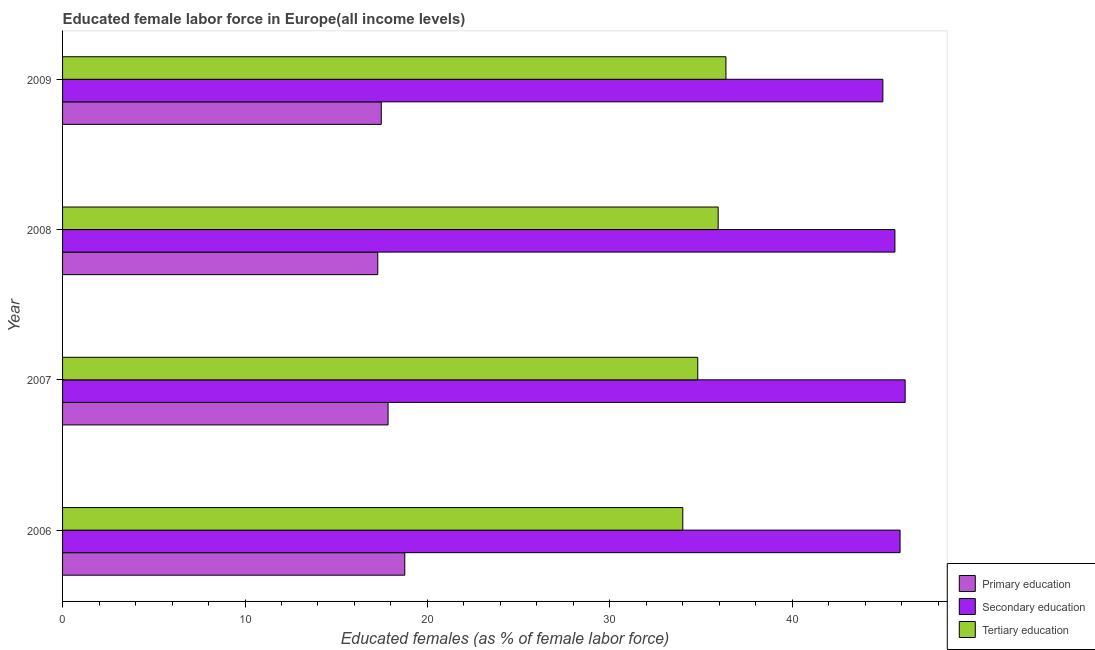How many different coloured bars are there?
Offer a very short reply. 3. How many groups of bars are there?
Your answer should be compact. 4. Are the number of bars per tick equal to the number of legend labels?
Offer a terse response. Yes. Are the number of bars on each tick of the Y-axis equal?
Make the answer very short. Yes. How many bars are there on the 3rd tick from the top?
Keep it short and to the point. 3. How many bars are there on the 3rd tick from the bottom?
Your answer should be compact. 3. What is the percentage of female labor force who received tertiary education in 2007?
Keep it short and to the point. 34.82. Across all years, what is the maximum percentage of female labor force who received primary education?
Provide a succinct answer. 18.76. Across all years, what is the minimum percentage of female labor force who received tertiary education?
Offer a very short reply. 34. In which year was the percentage of female labor force who received primary education minimum?
Your answer should be compact. 2008. What is the total percentage of female labor force who received tertiary education in the graph?
Ensure brevity in your answer.  141.11. What is the difference between the percentage of female labor force who received tertiary education in 2008 and that in 2009?
Make the answer very short. -0.42. What is the difference between the percentage of female labor force who received tertiary education in 2007 and the percentage of female labor force who received primary education in 2009?
Your answer should be compact. 17.35. What is the average percentage of female labor force who received tertiary education per year?
Your answer should be compact. 35.28. In the year 2007, what is the difference between the percentage of female labor force who received primary education and percentage of female labor force who received secondary education?
Ensure brevity in your answer.  -28.34. In how many years, is the percentage of female labor force who received tertiary education greater than 30 %?
Keep it short and to the point. 4. What is the ratio of the percentage of female labor force who received primary education in 2008 to that in 2009?
Make the answer very short. 0.99. What is the difference between the highest and the second highest percentage of female labor force who received primary education?
Offer a very short reply. 0.92. What is the difference between the highest and the lowest percentage of female labor force who received tertiary education?
Your answer should be compact. 2.36. Is the sum of the percentage of female labor force who received primary education in 2006 and 2008 greater than the maximum percentage of female labor force who received secondary education across all years?
Offer a very short reply. No. What does the 2nd bar from the top in 2008 represents?
Make the answer very short. Secondary education. What does the 3rd bar from the bottom in 2008 represents?
Ensure brevity in your answer.  Tertiary education. How many bars are there?
Offer a very short reply. 12. Are all the bars in the graph horizontal?
Ensure brevity in your answer.  Yes. How many years are there in the graph?
Provide a short and direct response. 4. What is the difference between two consecutive major ticks on the X-axis?
Your response must be concise. 10. Does the graph contain grids?
Provide a short and direct response. No. How many legend labels are there?
Ensure brevity in your answer.  3. What is the title of the graph?
Keep it short and to the point. Educated female labor force in Europe(all income levels). What is the label or title of the X-axis?
Keep it short and to the point. Educated females (as % of female labor force). What is the Educated females (as % of female labor force) of Primary education in 2006?
Provide a short and direct response. 18.76. What is the Educated females (as % of female labor force) of Secondary education in 2006?
Give a very brief answer. 45.91. What is the Educated females (as % of female labor force) in Tertiary education in 2006?
Give a very brief answer. 34. What is the Educated females (as % of female labor force) of Primary education in 2007?
Give a very brief answer. 17.84. What is the Educated females (as % of female labor force) of Secondary education in 2007?
Keep it short and to the point. 46.18. What is the Educated females (as % of female labor force) of Tertiary education in 2007?
Provide a short and direct response. 34.82. What is the Educated females (as % of female labor force) of Primary education in 2008?
Offer a very short reply. 17.28. What is the Educated females (as % of female labor force) in Secondary education in 2008?
Offer a terse response. 45.62. What is the Educated females (as % of female labor force) in Tertiary education in 2008?
Offer a very short reply. 35.94. What is the Educated females (as % of female labor force) in Primary education in 2009?
Your response must be concise. 17.47. What is the Educated females (as % of female labor force) in Secondary education in 2009?
Offer a very short reply. 44.96. What is the Educated females (as % of female labor force) in Tertiary education in 2009?
Provide a succinct answer. 36.36. Across all years, what is the maximum Educated females (as % of female labor force) in Primary education?
Offer a very short reply. 18.76. Across all years, what is the maximum Educated females (as % of female labor force) of Secondary education?
Ensure brevity in your answer.  46.18. Across all years, what is the maximum Educated females (as % of female labor force) in Tertiary education?
Provide a short and direct response. 36.36. Across all years, what is the minimum Educated females (as % of female labor force) of Primary education?
Your answer should be compact. 17.28. Across all years, what is the minimum Educated females (as % of female labor force) in Secondary education?
Keep it short and to the point. 44.96. Across all years, what is the minimum Educated females (as % of female labor force) in Tertiary education?
Offer a very short reply. 34. What is the total Educated females (as % of female labor force) in Primary education in the graph?
Offer a terse response. 71.35. What is the total Educated females (as % of female labor force) of Secondary education in the graph?
Your answer should be very brief. 182.68. What is the total Educated females (as % of female labor force) of Tertiary education in the graph?
Your response must be concise. 141.11. What is the difference between the Educated females (as % of female labor force) of Primary education in 2006 and that in 2007?
Give a very brief answer. 0.92. What is the difference between the Educated females (as % of female labor force) in Secondary education in 2006 and that in 2007?
Give a very brief answer. -0.28. What is the difference between the Educated females (as % of female labor force) of Tertiary education in 2006 and that in 2007?
Offer a terse response. -0.82. What is the difference between the Educated females (as % of female labor force) in Primary education in 2006 and that in 2008?
Make the answer very short. 1.48. What is the difference between the Educated females (as % of female labor force) of Secondary education in 2006 and that in 2008?
Offer a terse response. 0.28. What is the difference between the Educated females (as % of female labor force) of Tertiary education in 2006 and that in 2008?
Give a very brief answer. -1.94. What is the difference between the Educated females (as % of female labor force) of Primary education in 2006 and that in 2009?
Your answer should be compact. 1.29. What is the difference between the Educated females (as % of female labor force) in Secondary education in 2006 and that in 2009?
Your response must be concise. 0.94. What is the difference between the Educated females (as % of female labor force) of Tertiary education in 2006 and that in 2009?
Offer a terse response. -2.36. What is the difference between the Educated females (as % of female labor force) of Primary education in 2007 and that in 2008?
Provide a short and direct response. 0.56. What is the difference between the Educated females (as % of female labor force) of Secondary education in 2007 and that in 2008?
Give a very brief answer. 0.56. What is the difference between the Educated females (as % of female labor force) in Tertiary education in 2007 and that in 2008?
Offer a very short reply. -1.12. What is the difference between the Educated females (as % of female labor force) of Primary education in 2007 and that in 2009?
Give a very brief answer. 0.37. What is the difference between the Educated females (as % of female labor force) in Secondary education in 2007 and that in 2009?
Ensure brevity in your answer.  1.22. What is the difference between the Educated females (as % of female labor force) in Tertiary education in 2007 and that in 2009?
Your response must be concise. -1.54. What is the difference between the Educated females (as % of female labor force) in Primary education in 2008 and that in 2009?
Keep it short and to the point. -0.19. What is the difference between the Educated females (as % of female labor force) of Secondary education in 2008 and that in 2009?
Give a very brief answer. 0.66. What is the difference between the Educated females (as % of female labor force) of Tertiary education in 2008 and that in 2009?
Make the answer very short. -0.43. What is the difference between the Educated females (as % of female labor force) of Primary education in 2006 and the Educated females (as % of female labor force) of Secondary education in 2007?
Ensure brevity in your answer.  -27.43. What is the difference between the Educated females (as % of female labor force) in Primary education in 2006 and the Educated females (as % of female labor force) in Tertiary education in 2007?
Provide a succinct answer. -16.06. What is the difference between the Educated females (as % of female labor force) of Secondary education in 2006 and the Educated females (as % of female labor force) of Tertiary education in 2007?
Keep it short and to the point. 11.09. What is the difference between the Educated females (as % of female labor force) in Primary education in 2006 and the Educated females (as % of female labor force) in Secondary education in 2008?
Provide a succinct answer. -26.87. What is the difference between the Educated females (as % of female labor force) in Primary education in 2006 and the Educated females (as % of female labor force) in Tertiary education in 2008?
Provide a succinct answer. -17.18. What is the difference between the Educated females (as % of female labor force) of Secondary education in 2006 and the Educated females (as % of female labor force) of Tertiary education in 2008?
Offer a terse response. 9.97. What is the difference between the Educated females (as % of female labor force) of Primary education in 2006 and the Educated females (as % of female labor force) of Secondary education in 2009?
Provide a short and direct response. -26.21. What is the difference between the Educated females (as % of female labor force) in Primary education in 2006 and the Educated females (as % of female labor force) in Tertiary education in 2009?
Your response must be concise. -17.6. What is the difference between the Educated females (as % of female labor force) of Secondary education in 2006 and the Educated females (as % of female labor force) of Tertiary education in 2009?
Provide a succinct answer. 9.54. What is the difference between the Educated females (as % of female labor force) in Primary education in 2007 and the Educated females (as % of female labor force) in Secondary education in 2008?
Make the answer very short. -27.78. What is the difference between the Educated females (as % of female labor force) of Primary education in 2007 and the Educated females (as % of female labor force) of Tertiary education in 2008?
Make the answer very short. -18.09. What is the difference between the Educated females (as % of female labor force) of Secondary education in 2007 and the Educated females (as % of female labor force) of Tertiary education in 2008?
Offer a very short reply. 10.25. What is the difference between the Educated females (as % of female labor force) in Primary education in 2007 and the Educated females (as % of female labor force) in Secondary education in 2009?
Your answer should be very brief. -27.12. What is the difference between the Educated females (as % of female labor force) in Primary education in 2007 and the Educated females (as % of female labor force) in Tertiary education in 2009?
Make the answer very short. -18.52. What is the difference between the Educated females (as % of female labor force) of Secondary education in 2007 and the Educated females (as % of female labor force) of Tertiary education in 2009?
Ensure brevity in your answer.  9.82. What is the difference between the Educated females (as % of female labor force) in Primary education in 2008 and the Educated females (as % of female labor force) in Secondary education in 2009?
Offer a very short reply. -27.68. What is the difference between the Educated females (as % of female labor force) in Primary education in 2008 and the Educated females (as % of female labor force) in Tertiary education in 2009?
Offer a terse response. -19.08. What is the difference between the Educated females (as % of female labor force) of Secondary education in 2008 and the Educated females (as % of female labor force) of Tertiary education in 2009?
Give a very brief answer. 9.26. What is the average Educated females (as % of female labor force) in Primary education per year?
Your answer should be compact. 17.84. What is the average Educated females (as % of female labor force) in Secondary education per year?
Offer a terse response. 45.67. What is the average Educated females (as % of female labor force) of Tertiary education per year?
Your answer should be compact. 35.28. In the year 2006, what is the difference between the Educated females (as % of female labor force) in Primary education and Educated females (as % of female labor force) in Secondary education?
Ensure brevity in your answer.  -27.15. In the year 2006, what is the difference between the Educated females (as % of female labor force) in Primary education and Educated females (as % of female labor force) in Tertiary education?
Keep it short and to the point. -15.24. In the year 2006, what is the difference between the Educated females (as % of female labor force) in Secondary education and Educated females (as % of female labor force) in Tertiary education?
Make the answer very short. 11.91. In the year 2007, what is the difference between the Educated females (as % of female labor force) in Primary education and Educated females (as % of female labor force) in Secondary education?
Give a very brief answer. -28.34. In the year 2007, what is the difference between the Educated females (as % of female labor force) in Primary education and Educated females (as % of female labor force) in Tertiary education?
Offer a very short reply. -16.97. In the year 2007, what is the difference between the Educated females (as % of female labor force) in Secondary education and Educated females (as % of female labor force) in Tertiary education?
Provide a short and direct response. 11.37. In the year 2008, what is the difference between the Educated females (as % of female labor force) of Primary education and Educated females (as % of female labor force) of Secondary education?
Provide a short and direct response. -28.35. In the year 2008, what is the difference between the Educated females (as % of female labor force) of Primary education and Educated females (as % of female labor force) of Tertiary education?
Your response must be concise. -18.66. In the year 2008, what is the difference between the Educated females (as % of female labor force) in Secondary education and Educated females (as % of female labor force) in Tertiary education?
Your response must be concise. 9.69. In the year 2009, what is the difference between the Educated females (as % of female labor force) of Primary education and Educated females (as % of female labor force) of Secondary education?
Your answer should be very brief. -27.49. In the year 2009, what is the difference between the Educated females (as % of female labor force) of Primary education and Educated females (as % of female labor force) of Tertiary education?
Make the answer very short. -18.89. In the year 2009, what is the difference between the Educated females (as % of female labor force) in Secondary education and Educated females (as % of female labor force) in Tertiary education?
Ensure brevity in your answer.  8.6. What is the ratio of the Educated females (as % of female labor force) of Primary education in 2006 to that in 2007?
Make the answer very short. 1.05. What is the ratio of the Educated females (as % of female labor force) in Tertiary education in 2006 to that in 2007?
Provide a succinct answer. 0.98. What is the ratio of the Educated females (as % of female labor force) of Primary education in 2006 to that in 2008?
Your answer should be compact. 1.09. What is the ratio of the Educated females (as % of female labor force) in Tertiary education in 2006 to that in 2008?
Your answer should be very brief. 0.95. What is the ratio of the Educated females (as % of female labor force) in Primary education in 2006 to that in 2009?
Offer a terse response. 1.07. What is the ratio of the Educated females (as % of female labor force) in Secondary education in 2006 to that in 2009?
Your response must be concise. 1.02. What is the ratio of the Educated females (as % of female labor force) of Tertiary education in 2006 to that in 2009?
Keep it short and to the point. 0.94. What is the ratio of the Educated females (as % of female labor force) in Primary education in 2007 to that in 2008?
Your answer should be very brief. 1.03. What is the ratio of the Educated females (as % of female labor force) of Secondary education in 2007 to that in 2008?
Make the answer very short. 1.01. What is the ratio of the Educated females (as % of female labor force) of Tertiary education in 2007 to that in 2008?
Make the answer very short. 0.97. What is the ratio of the Educated females (as % of female labor force) in Primary education in 2007 to that in 2009?
Provide a short and direct response. 1.02. What is the ratio of the Educated females (as % of female labor force) in Secondary education in 2007 to that in 2009?
Provide a short and direct response. 1.03. What is the ratio of the Educated females (as % of female labor force) in Tertiary education in 2007 to that in 2009?
Provide a succinct answer. 0.96. What is the ratio of the Educated females (as % of female labor force) of Primary education in 2008 to that in 2009?
Make the answer very short. 0.99. What is the ratio of the Educated females (as % of female labor force) of Secondary education in 2008 to that in 2009?
Make the answer very short. 1.01. What is the ratio of the Educated females (as % of female labor force) in Tertiary education in 2008 to that in 2009?
Offer a very short reply. 0.99. What is the difference between the highest and the second highest Educated females (as % of female labor force) in Primary education?
Your answer should be very brief. 0.92. What is the difference between the highest and the second highest Educated females (as % of female labor force) of Secondary education?
Ensure brevity in your answer.  0.28. What is the difference between the highest and the second highest Educated females (as % of female labor force) in Tertiary education?
Offer a very short reply. 0.43. What is the difference between the highest and the lowest Educated females (as % of female labor force) of Primary education?
Provide a succinct answer. 1.48. What is the difference between the highest and the lowest Educated females (as % of female labor force) in Secondary education?
Ensure brevity in your answer.  1.22. What is the difference between the highest and the lowest Educated females (as % of female labor force) in Tertiary education?
Provide a succinct answer. 2.36. 